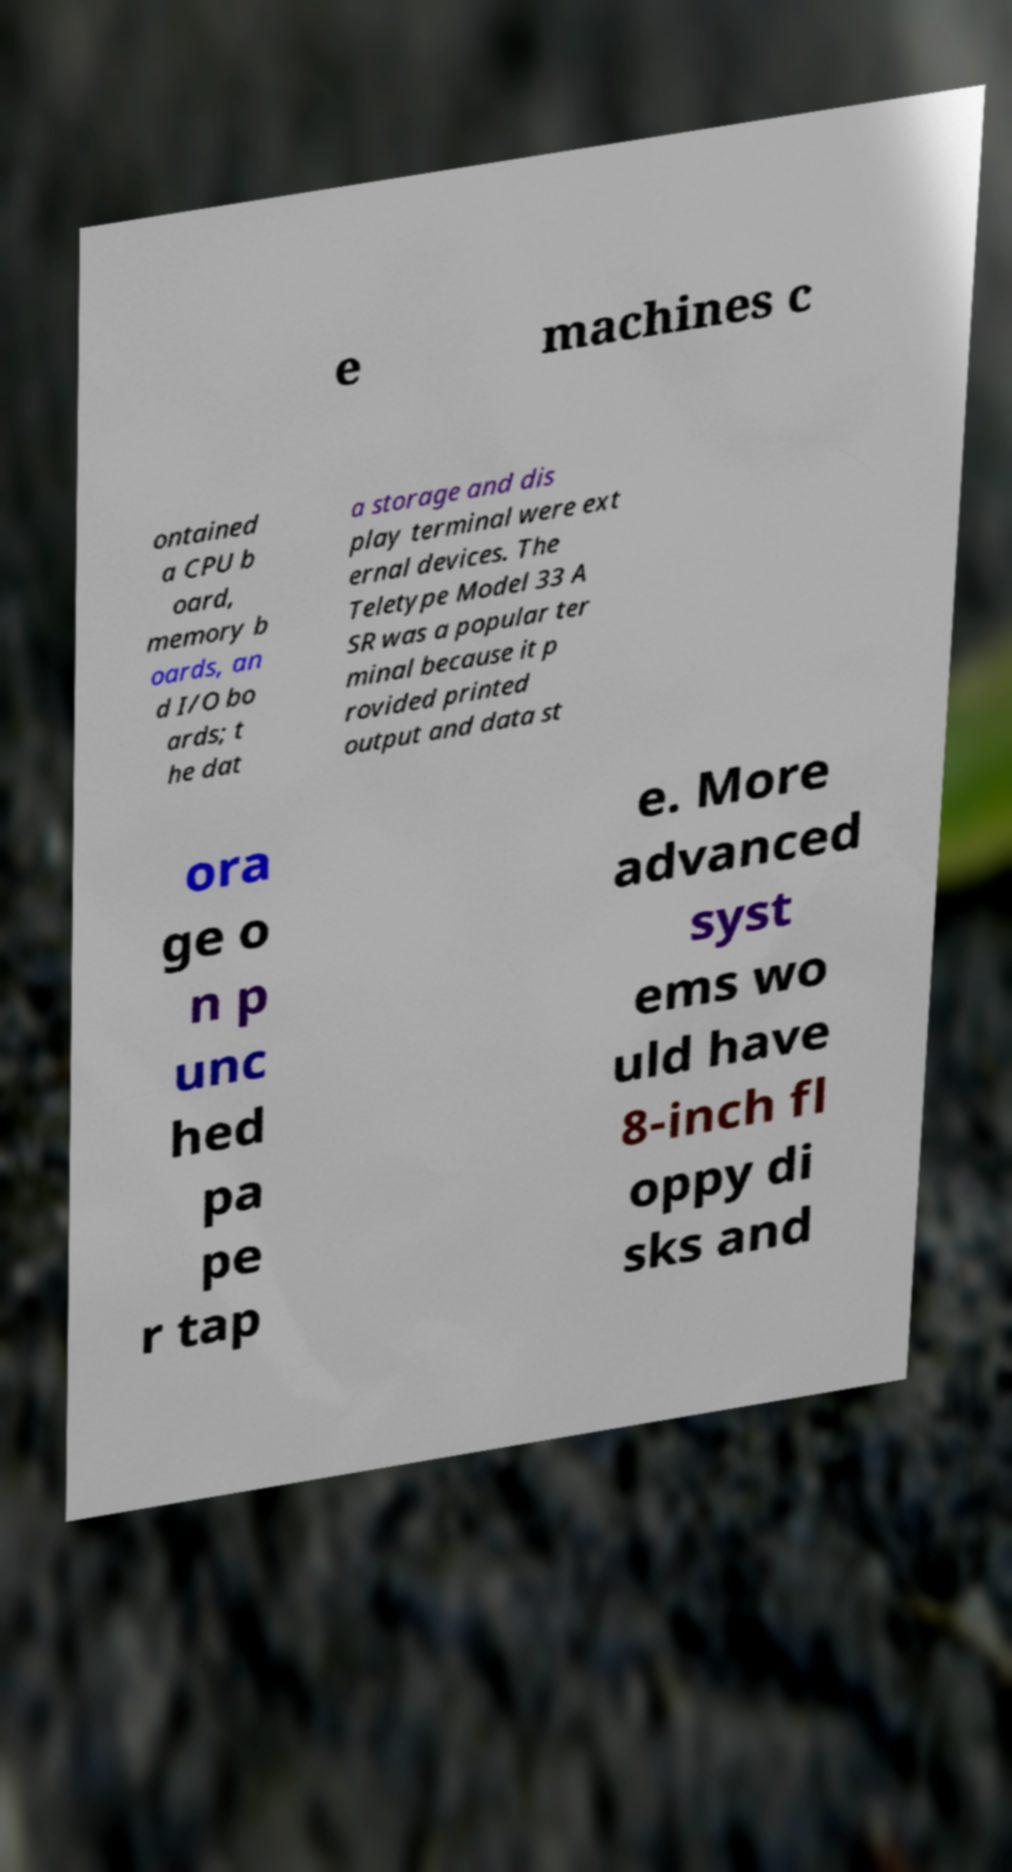I need the written content from this picture converted into text. Can you do that? e machines c ontained a CPU b oard, memory b oards, an d I/O bo ards; t he dat a storage and dis play terminal were ext ernal devices. The Teletype Model 33 A SR was a popular ter minal because it p rovided printed output and data st ora ge o n p unc hed pa pe r tap e. More advanced syst ems wo uld have 8-inch fl oppy di sks and 